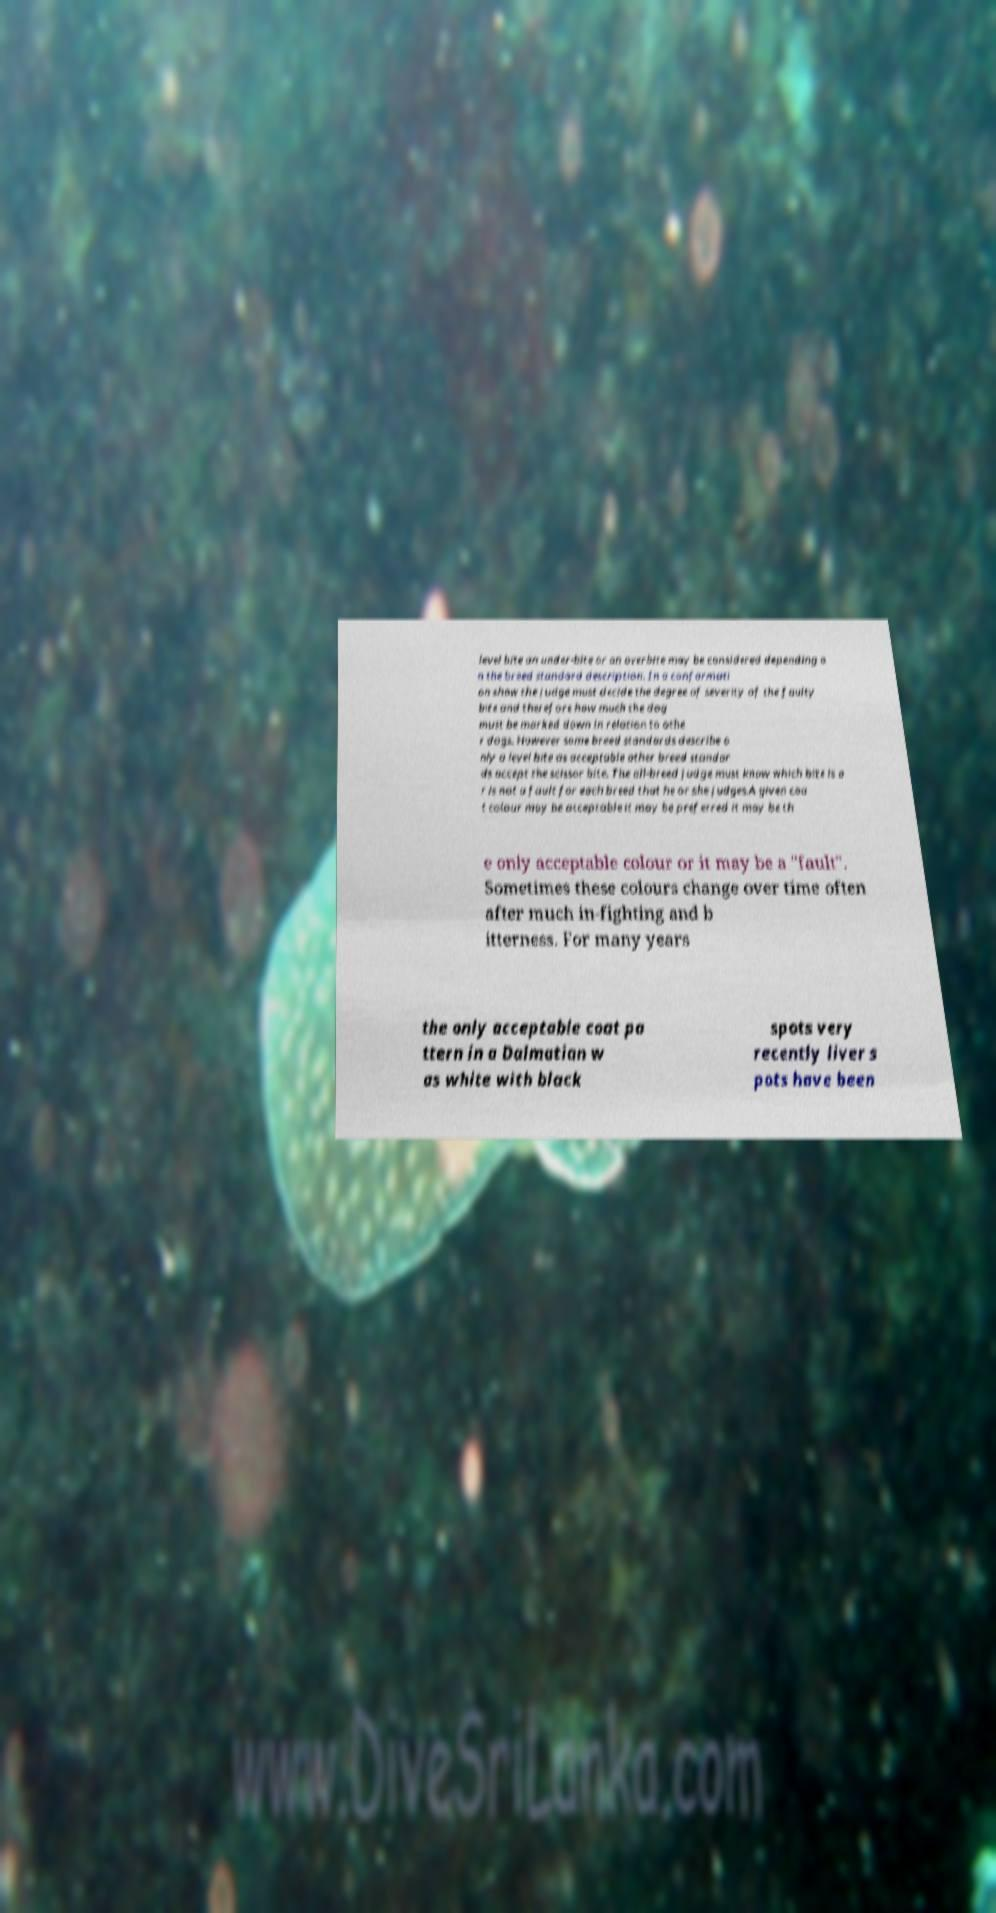Could you extract and type out the text from this image? level bite an under-bite or an overbite may be considered depending o n the breed standard description. In a conformati on show the judge must decide the degree of severity of the faulty bite and therefore how much the dog must be marked down in relation to othe r dogs. However some breed standards describe o nly a level bite as acceptable other breed standar ds accept the scissor bite. The all-breed judge must know which bite is o r is not a fault for each breed that he or she judges.A given coa t colour may be acceptable it may be preferred it may be th e only acceptable colour or it may be a "fault". Sometimes these colours change over time often after much in-fighting and b itterness. For many years the only acceptable coat pa ttern in a Dalmatian w as white with black spots very recently liver s pots have been 